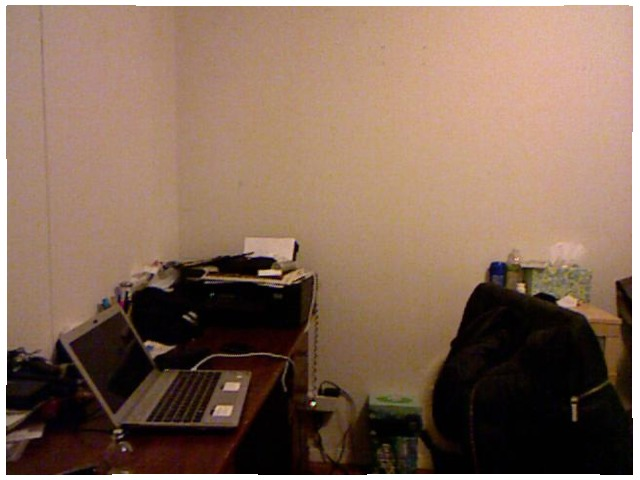<image>
Is there a laptop on the table? Yes. Looking at the image, I can see the laptop is positioned on top of the table, with the table providing support. Is there a laptop next to the printer? No. The laptop is not positioned next to the printer. They are located in different areas of the scene. Where is the wire in relation to the wall? Is it in the wall? No. The wire is not contained within the wall. These objects have a different spatial relationship. 